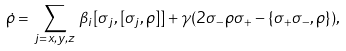Convert formula to latex. <formula><loc_0><loc_0><loc_500><loc_500>\dot { \rho } = \, \sum _ { j = x , y , z } \, \beta _ { i } [ \sigma _ { j } , [ \sigma _ { j } , \rho ] ] + \gamma ( 2 \sigma _ { - } \rho \sigma _ { + } - \{ \sigma _ { + } \sigma _ { - } , \rho \} ) ,</formula> 